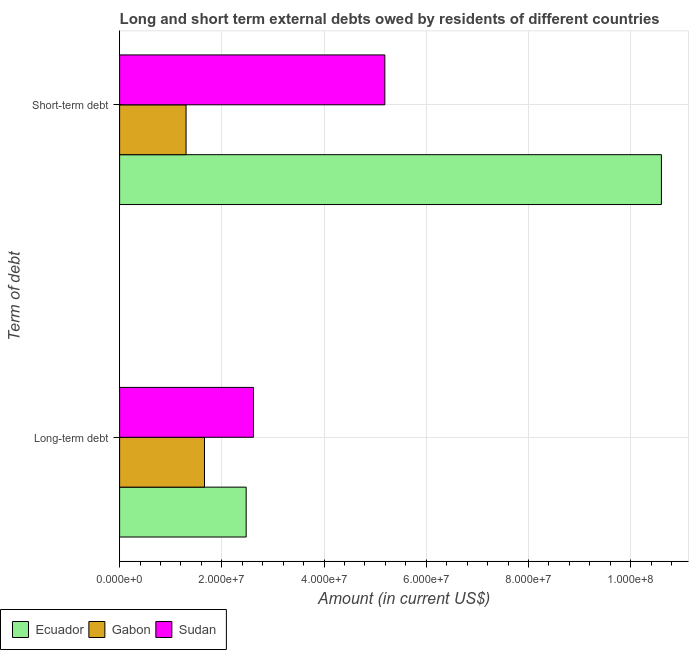Are the number of bars per tick equal to the number of legend labels?
Make the answer very short. Yes. Are the number of bars on each tick of the Y-axis equal?
Provide a short and direct response. Yes. How many bars are there on the 2nd tick from the bottom?
Provide a short and direct response. 3. What is the label of the 2nd group of bars from the top?
Provide a short and direct response. Long-term debt. What is the long-term debts owed by residents in Gabon?
Make the answer very short. 1.66e+07. Across all countries, what is the maximum short-term debts owed by residents?
Give a very brief answer. 1.06e+08. Across all countries, what is the minimum short-term debts owed by residents?
Provide a short and direct response. 1.30e+07. In which country was the long-term debts owed by residents maximum?
Your answer should be compact. Sudan. In which country was the short-term debts owed by residents minimum?
Your response must be concise. Gabon. What is the total long-term debts owed by residents in the graph?
Provide a succinct answer. 6.76e+07. What is the difference between the short-term debts owed by residents in Ecuador and that in Sudan?
Your answer should be compact. 5.41e+07. What is the difference between the short-term debts owed by residents in Sudan and the long-term debts owed by residents in Ecuador?
Provide a succinct answer. 2.71e+07. What is the average long-term debts owed by residents per country?
Keep it short and to the point. 2.25e+07. What is the difference between the short-term debts owed by residents and long-term debts owed by residents in Ecuador?
Give a very brief answer. 8.12e+07. What is the ratio of the short-term debts owed by residents in Gabon to that in Ecuador?
Offer a terse response. 0.12. What does the 3rd bar from the top in Long-term debt represents?
Make the answer very short. Ecuador. What does the 3rd bar from the bottom in Short-term debt represents?
Give a very brief answer. Sudan. How many countries are there in the graph?
Ensure brevity in your answer.  3. Are the values on the major ticks of X-axis written in scientific E-notation?
Keep it short and to the point. Yes. Does the graph contain any zero values?
Offer a terse response. No. How many legend labels are there?
Make the answer very short. 3. How are the legend labels stacked?
Give a very brief answer. Horizontal. What is the title of the graph?
Your response must be concise. Long and short term external debts owed by residents of different countries. Does "Cabo Verde" appear as one of the legend labels in the graph?
Give a very brief answer. No. What is the label or title of the Y-axis?
Ensure brevity in your answer.  Term of debt. What is the Amount (in current US$) of Ecuador in Long-term debt?
Ensure brevity in your answer.  2.48e+07. What is the Amount (in current US$) of Gabon in Long-term debt?
Your response must be concise. 1.66e+07. What is the Amount (in current US$) of Sudan in Long-term debt?
Provide a short and direct response. 2.62e+07. What is the Amount (in current US$) in Ecuador in Short-term debt?
Provide a succinct answer. 1.06e+08. What is the Amount (in current US$) of Gabon in Short-term debt?
Ensure brevity in your answer.  1.30e+07. What is the Amount (in current US$) in Sudan in Short-term debt?
Make the answer very short. 5.19e+07. Across all Term of debt, what is the maximum Amount (in current US$) of Ecuador?
Offer a terse response. 1.06e+08. Across all Term of debt, what is the maximum Amount (in current US$) in Gabon?
Give a very brief answer. 1.66e+07. Across all Term of debt, what is the maximum Amount (in current US$) in Sudan?
Keep it short and to the point. 5.19e+07. Across all Term of debt, what is the minimum Amount (in current US$) in Ecuador?
Make the answer very short. 2.48e+07. Across all Term of debt, what is the minimum Amount (in current US$) of Gabon?
Provide a short and direct response. 1.30e+07. Across all Term of debt, what is the minimum Amount (in current US$) in Sudan?
Provide a short and direct response. 2.62e+07. What is the total Amount (in current US$) of Ecuador in the graph?
Your answer should be very brief. 1.31e+08. What is the total Amount (in current US$) in Gabon in the graph?
Your answer should be very brief. 2.96e+07. What is the total Amount (in current US$) in Sudan in the graph?
Provide a short and direct response. 7.81e+07. What is the difference between the Amount (in current US$) of Ecuador in Long-term debt and that in Short-term debt?
Your answer should be compact. -8.12e+07. What is the difference between the Amount (in current US$) in Gabon in Long-term debt and that in Short-term debt?
Ensure brevity in your answer.  3.61e+06. What is the difference between the Amount (in current US$) of Sudan in Long-term debt and that in Short-term debt?
Provide a short and direct response. -2.57e+07. What is the difference between the Amount (in current US$) of Ecuador in Long-term debt and the Amount (in current US$) of Gabon in Short-term debt?
Offer a very short reply. 1.18e+07. What is the difference between the Amount (in current US$) of Ecuador in Long-term debt and the Amount (in current US$) of Sudan in Short-term debt?
Keep it short and to the point. -2.71e+07. What is the difference between the Amount (in current US$) in Gabon in Long-term debt and the Amount (in current US$) in Sudan in Short-term debt?
Provide a succinct answer. -3.53e+07. What is the average Amount (in current US$) in Ecuador per Term of debt?
Offer a terse response. 6.54e+07. What is the average Amount (in current US$) in Gabon per Term of debt?
Give a very brief answer. 1.48e+07. What is the average Amount (in current US$) in Sudan per Term of debt?
Ensure brevity in your answer.  3.90e+07. What is the difference between the Amount (in current US$) of Ecuador and Amount (in current US$) of Gabon in Long-term debt?
Your response must be concise. 8.15e+06. What is the difference between the Amount (in current US$) in Ecuador and Amount (in current US$) in Sudan in Long-term debt?
Your answer should be very brief. -1.43e+06. What is the difference between the Amount (in current US$) of Gabon and Amount (in current US$) of Sudan in Long-term debt?
Provide a short and direct response. -9.58e+06. What is the difference between the Amount (in current US$) of Ecuador and Amount (in current US$) of Gabon in Short-term debt?
Provide a succinct answer. 9.30e+07. What is the difference between the Amount (in current US$) of Ecuador and Amount (in current US$) of Sudan in Short-term debt?
Offer a terse response. 5.41e+07. What is the difference between the Amount (in current US$) in Gabon and Amount (in current US$) in Sudan in Short-term debt?
Provide a succinct answer. -3.89e+07. What is the ratio of the Amount (in current US$) of Ecuador in Long-term debt to that in Short-term debt?
Give a very brief answer. 0.23. What is the ratio of the Amount (in current US$) of Gabon in Long-term debt to that in Short-term debt?
Your answer should be very brief. 1.28. What is the ratio of the Amount (in current US$) in Sudan in Long-term debt to that in Short-term debt?
Offer a very short reply. 0.5. What is the difference between the highest and the second highest Amount (in current US$) of Ecuador?
Keep it short and to the point. 8.12e+07. What is the difference between the highest and the second highest Amount (in current US$) in Gabon?
Offer a terse response. 3.61e+06. What is the difference between the highest and the second highest Amount (in current US$) of Sudan?
Offer a very short reply. 2.57e+07. What is the difference between the highest and the lowest Amount (in current US$) in Ecuador?
Keep it short and to the point. 8.12e+07. What is the difference between the highest and the lowest Amount (in current US$) of Gabon?
Your answer should be very brief. 3.61e+06. What is the difference between the highest and the lowest Amount (in current US$) in Sudan?
Make the answer very short. 2.57e+07. 